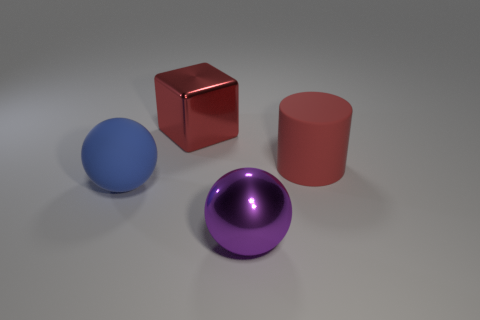Are there fewer purple metal spheres that are behind the blue object than blue matte spheres that are on the right side of the red block?
Your response must be concise. No. How many things are metal objects or large red metal things?
Offer a very short reply. 2. What number of big red things are left of the big cylinder?
Make the answer very short. 1. Do the large rubber cylinder and the big metallic block have the same color?
Provide a succinct answer. Yes. What is the shape of the red thing that is the same material as the purple thing?
Ensure brevity in your answer.  Cube. Does the metallic thing in front of the shiny cube have the same shape as the blue thing?
Make the answer very short. Yes. What number of brown objects are cubes or rubber cylinders?
Your response must be concise. 0. Is the number of big red matte cylinders to the left of the large blue object the same as the number of big red cubes that are in front of the matte cylinder?
Ensure brevity in your answer.  Yes. There is a sphere to the left of the big red object that is to the left of the big thing that is in front of the large blue rubber object; what is its color?
Offer a terse response. Blue. Is there any other thing of the same color as the cylinder?
Make the answer very short. Yes. 